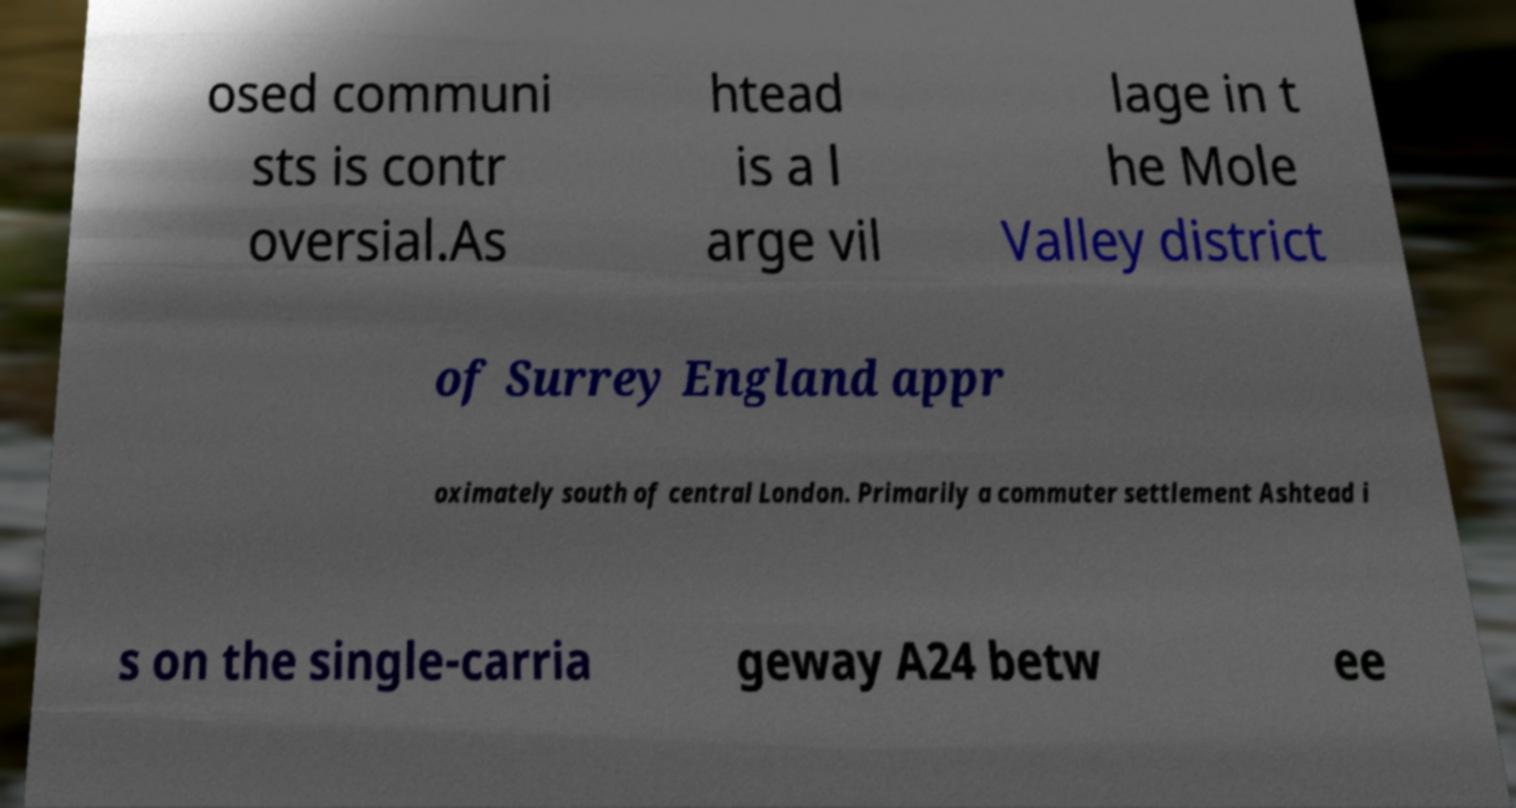Can you read and provide the text displayed in the image?This photo seems to have some interesting text. Can you extract and type it out for me? osed communi sts is contr oversial.As htead is a l arge vil lage in t he Mole Valley district of Surrey England appr oximately south of central London. Primarily a commuter settlement Ashtead i s on the single-carria geway A24 betw ee 